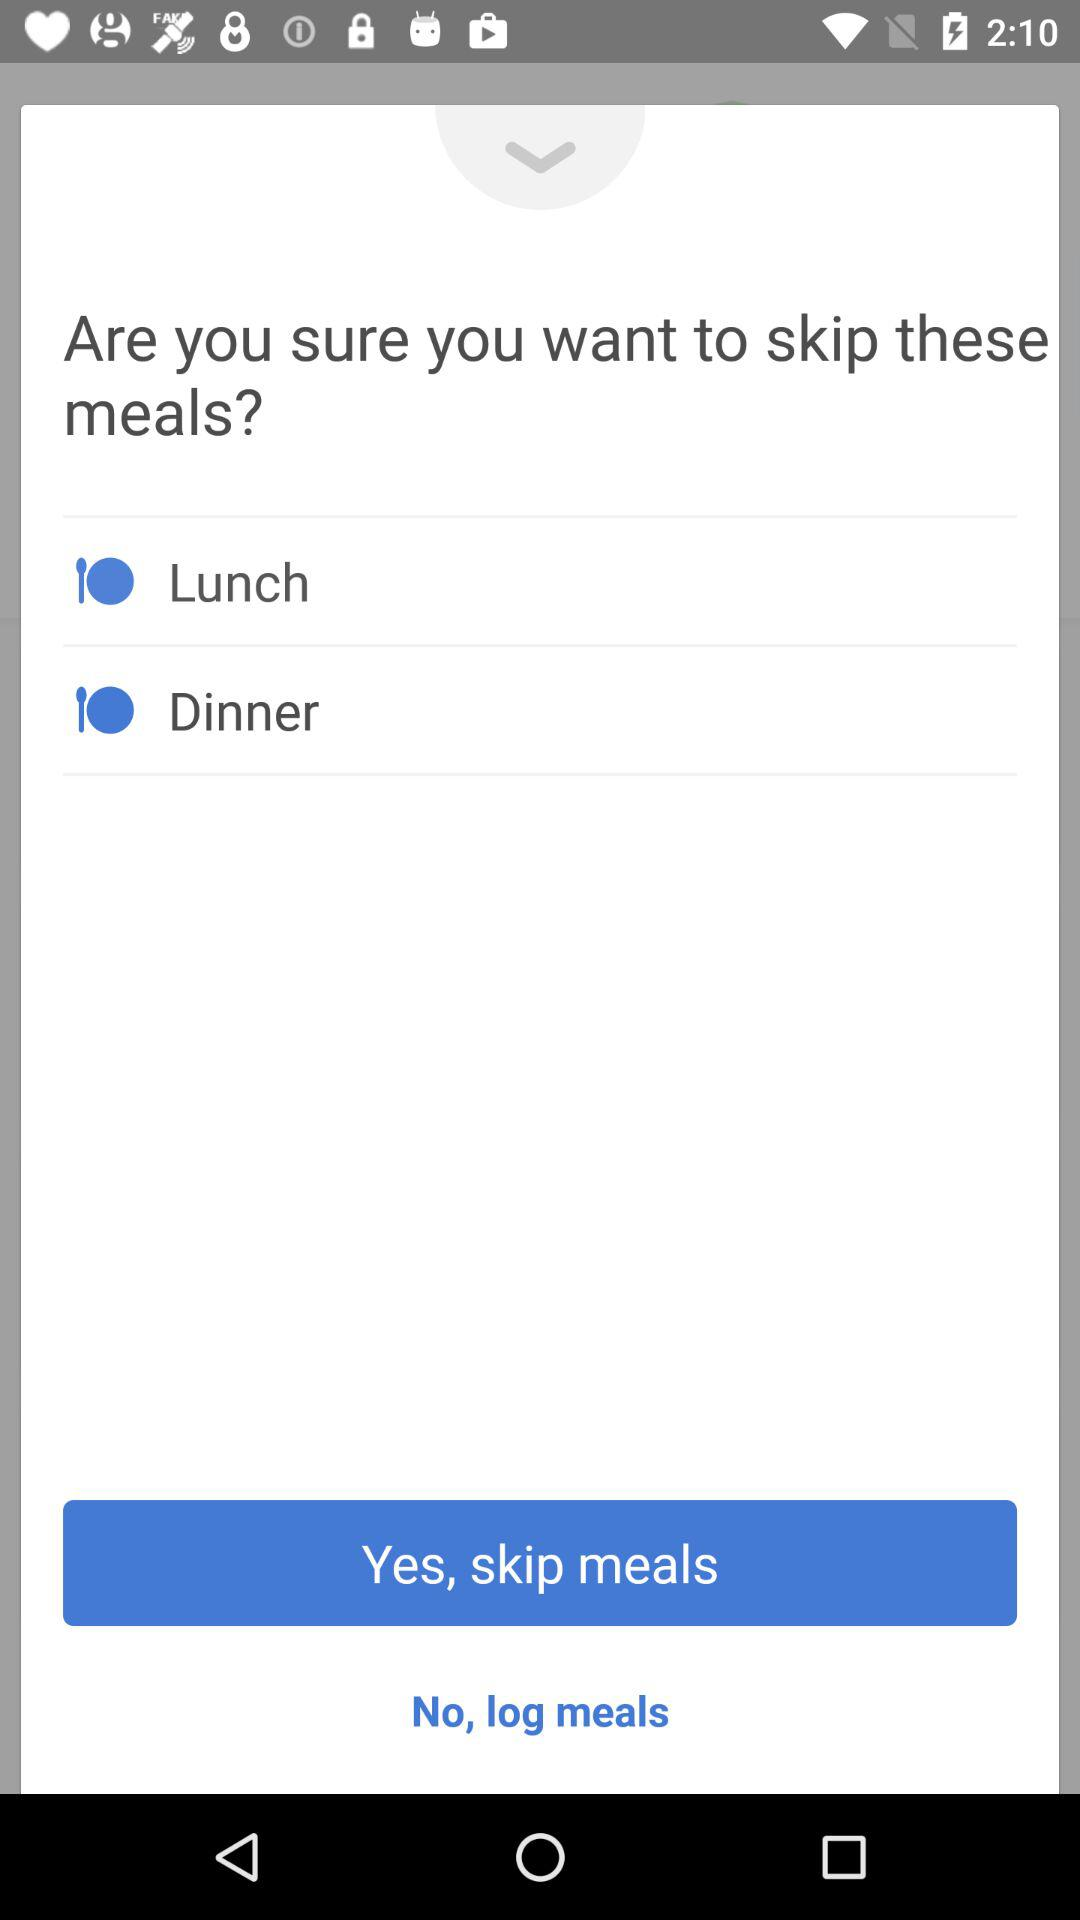How many meals are selected to be skipped?
Answer the question using a single word or phrase. 2 